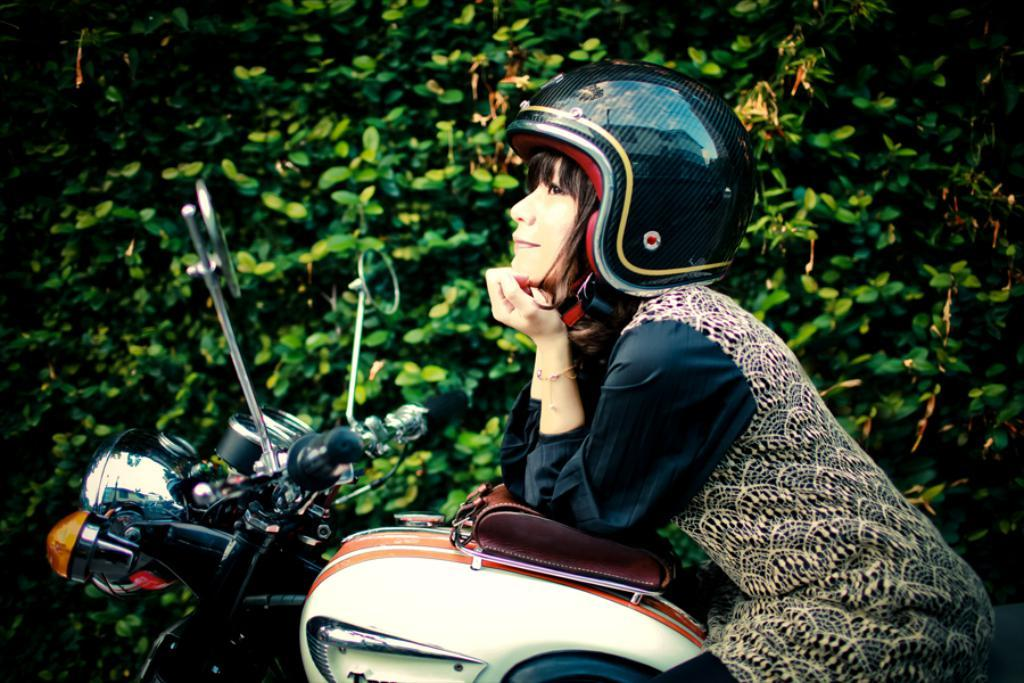Who is the main subject in the image? There is a woman in the image. What is the woman doing in the image? The woman is sitting on a bike. What can be seen in the background of the image? There are trees beside the woman. How many bears are sitting on the bridge in the image? There is no bridge or bears present in the image. What type of machine is being used by the woman in the image? The image does not show the woman using any machine; she is sitting on a bike. 